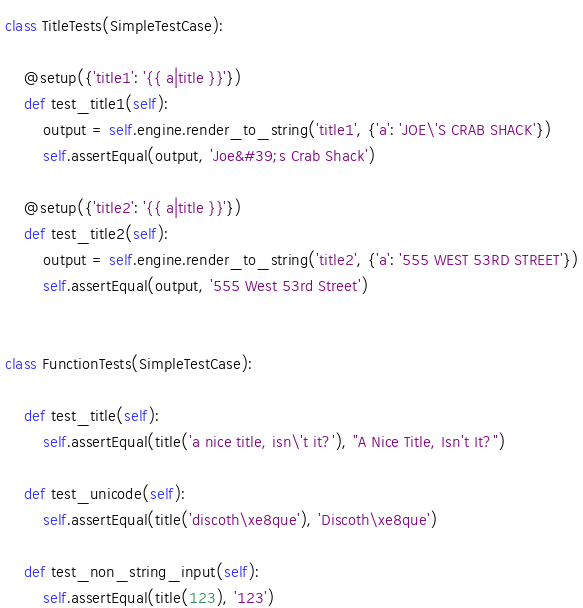<code> <loc_0><loc_0><loc_500><loc_500><_Python_>
class TitleTests(SimpleTestCase):

    @setup({'title1': '{{ a|title }}'})
    def test_title1(self):
        output = self.engine.render_to_string('title1', {'a': 'JOE\'S CRAB SHACK'})
        self.assertEqual(output, 'Joe&#39;s Crab Shack')

    @setup({'title2': '{{ a|title }}'})
    def test_title2(self):
        output = self.engine.render_to_string('title2', {'a': '555 WEST 53RD STREET'})
        self.assertEqual(output, '555 West 53rd Street')


class FunctionTests(SimpleTestCase):

    def test_title(self):
        self.assertEqual(title('a nice title, isn\'t it?'), "A Nice Title, Isn't It?")

    def test_unicode(self):
        self.assertEqual(title('discoth\xe8que'), 'Discoth\xe8que')

    def test_non_string_input(self):
        self.assertEqual(title(123), '123')
</code> 